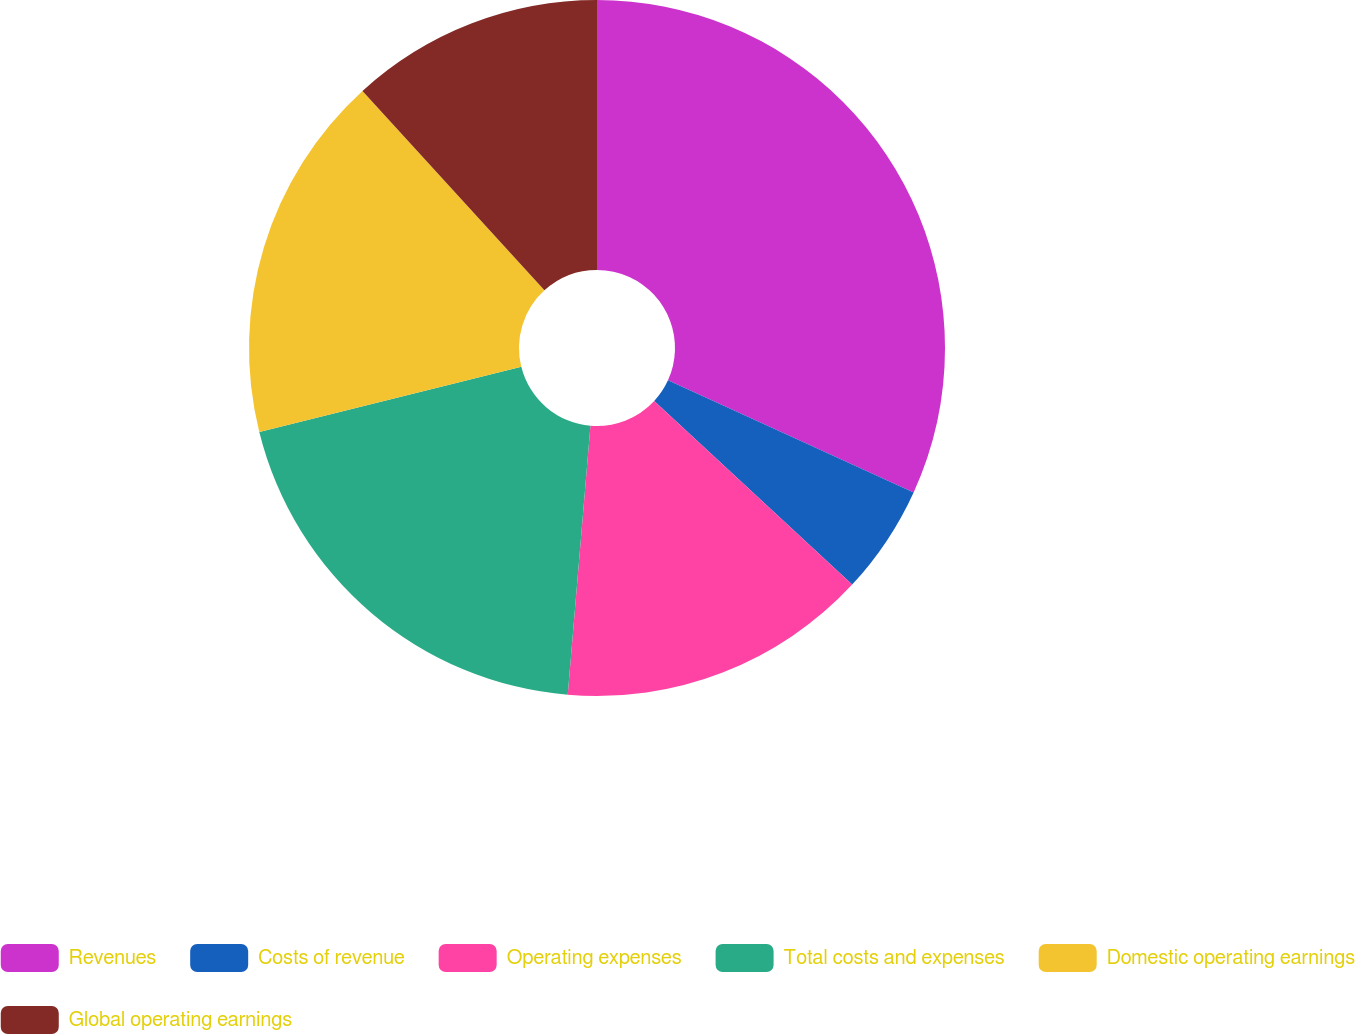<chart> <loc_0><loc_0><loc_500><loc_500><pie_chart><fcel>Revenues<fcel>Costs of revenue<fcel>Operating expenses<fcel>Total costs and expenses<fcel>Domestic operating earnings<fcel>Global operating earnings<nl><fcel>31.81%<fcel>5.09%<fcel>14.44%<fcel>19.78%<fcel>17.11%<fcel>11.77%<nl></chart> 